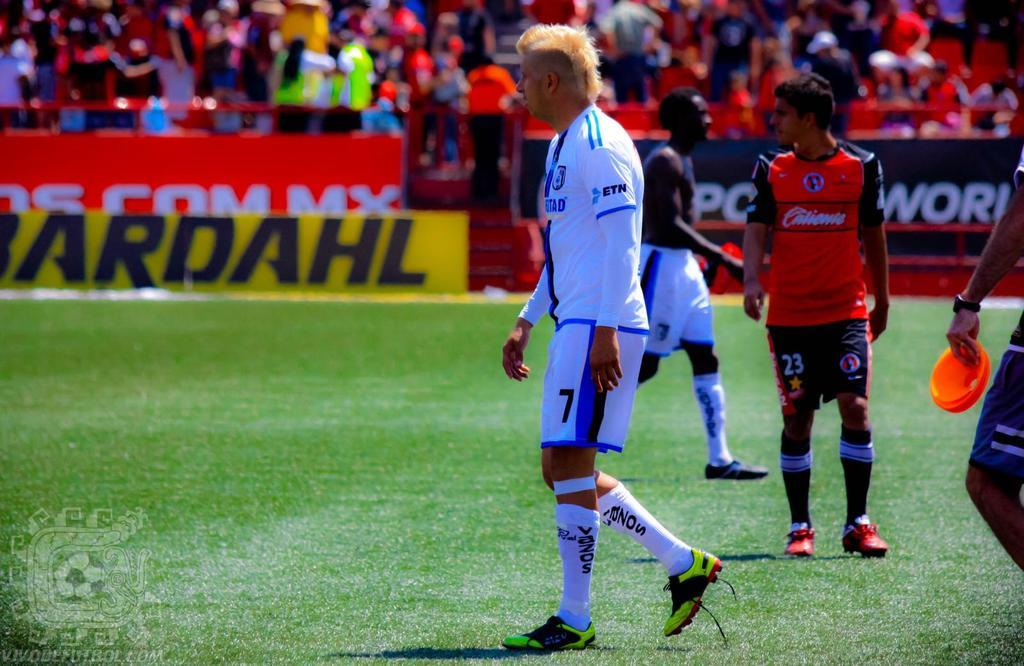<image>
Present a compact description of the photo's key features. Player number 7 wearing a white and blue uniform on a soccer field. 